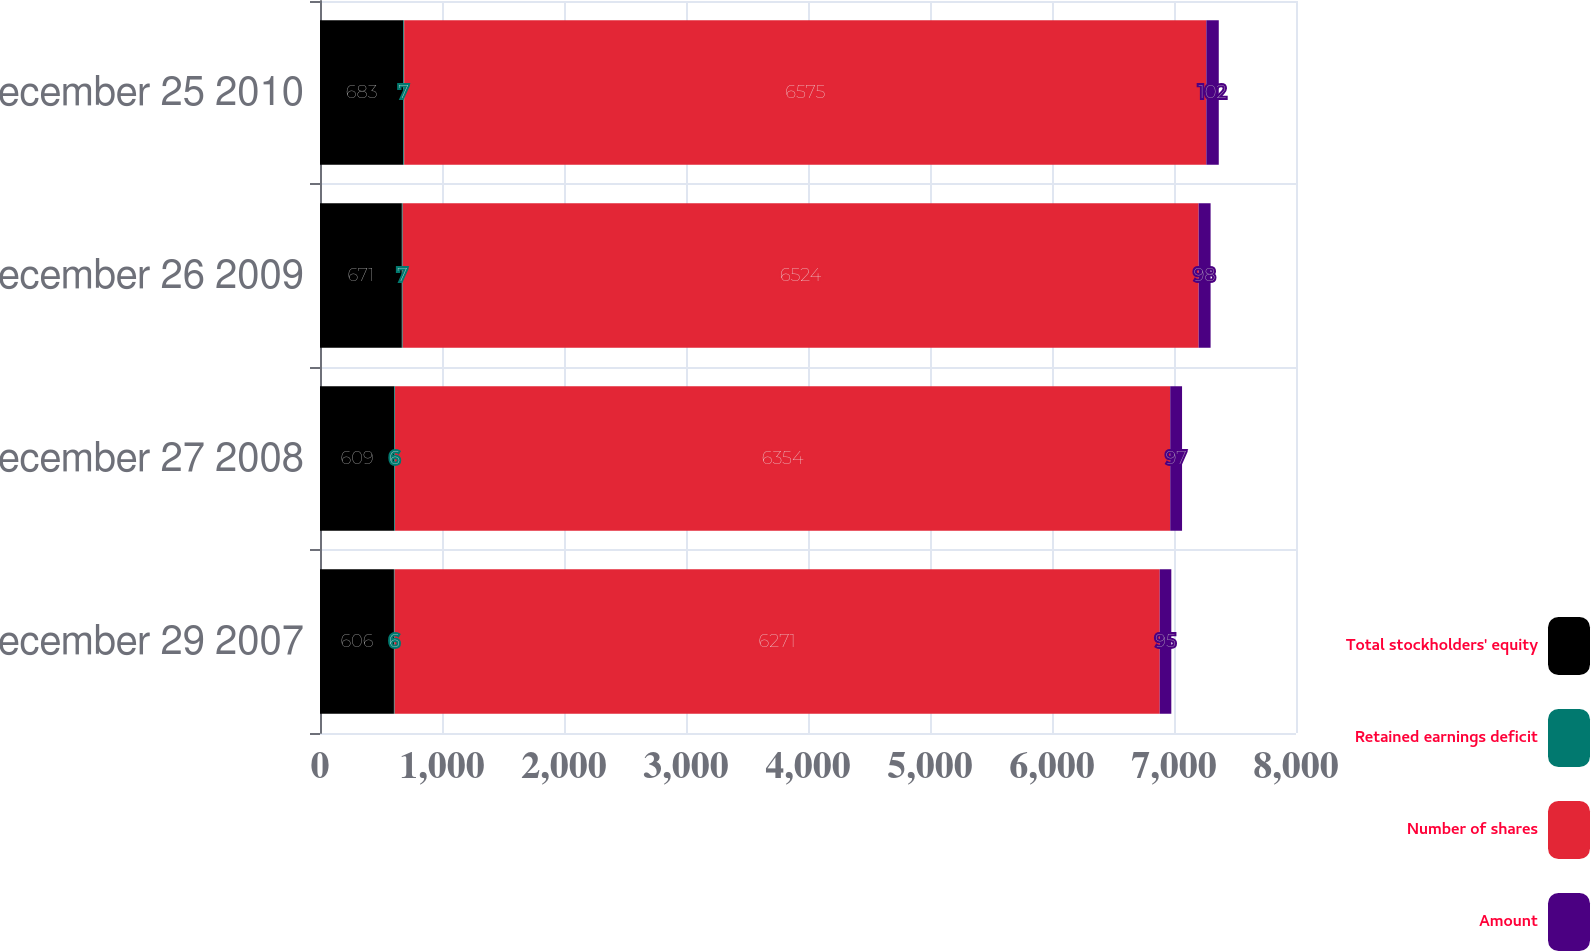Convert chart. <chart><loc_0><loc_0><loc_500><loc_500><stacked_bar_chart><ecel><fcel>December 29 2007<fcel>December 27 2008<fcel>December 26 2009<fcel>December 25 2010<nl><fcel>Total stockholders' equity<fcel>606<fcel>609<fcel>671<fcel>683<nl><fcel>Retained earnings deficit<fcel>6<fcel>6<fcel>7<fcel>7<nl><fcel>Number of shares<fcel>6271<fcel>6354<fcel>6524<fcel>6575<nl><fcel>Amount<fcel>95<fcel>97<fcel>98<fcel>102<nl></chart> 